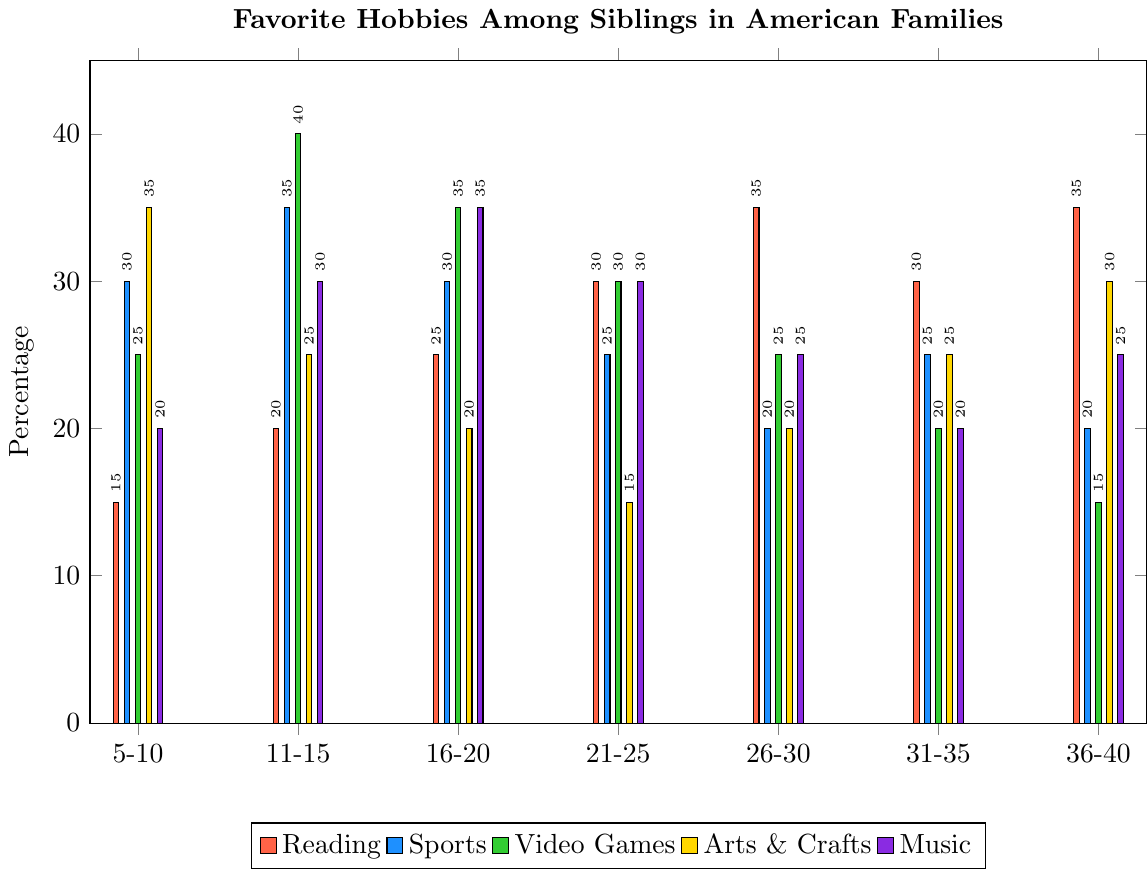What is the most popular hobby in the 5-10 age group? By looking at the heights of the bars for the 5-10 age group, we can see that “Outdoor Activities” has the tallest bar.
Answer: Outdoor Activities Which age group has the highest preference for "Video Games"? By comparing the height of the "Video Games" bars across all age groups, the highest preference is found in the 11-15 age group.
Answer: 11-15 How many age groups have "Reading" as their most popular hobby? We need to check the height of the "Reading" bars compared to others for each age group to see if it’s the highest. "Reading" is the tallest in the 26-30 and 36-40 age groups.
Answer: 2 Is "Music" more popular in the 16-20 age group or the 31-35 age group? By comparing the heights of the “Music” bars, we can see that the 16-20 age group has a taller bar for "Music" than the 31-35 age group.
Answer: 16-20 Which age group shows the least interest in "Social Media"? By looking at the heights of the “Social Media” bars across all age groups, the 5-10 age group has the shortest bar.
Answer: 5-10 What is the average percentage of preference for "Arts & Crafts" across all age groups? Add the percentages for “Arts & Crafts” from all age groups (35 + 25 + 20 + 15 + 20 + 25 + 30) and then divide by the number of age groups (7). The sum is 170, and the average is 170/7.
Answer: 24.29 In which age group is the popularity of "Sports" and "Music" equal? We look for age groups where the height of the “Sports” and “Music” bars match. This occurs in the 21-25 age group where both are 30.
Answer: 21-25 Which hobby has the most consistent popularity across all age groups? By examining the heights of the bars across age groups, “Cooking” shows relatively stable bars across the age groups without significant peaks or troughs.
Answer: Cooking Between the 21-25 and 26-30 age groups, which has a higher average percentage of preference for "Dancing"? Calculate the average for each group: 21-25 (5), 26-30 (10). The 26-30 age group has a higher average.
Answer: 26-30 Which hobbies have a visibly higher preference in the 36-40 age group compared to the 16-20 age group? Compare the heights of the bars for each hobby between 36-40 and 16-20. "Reading," "Arts & Crafts," and "Outdoor Activities" are taller in the 36-40 age group compared to the 16-20 age group.
Answer: Reading, Arts & Crafts, Outdoor Activities 